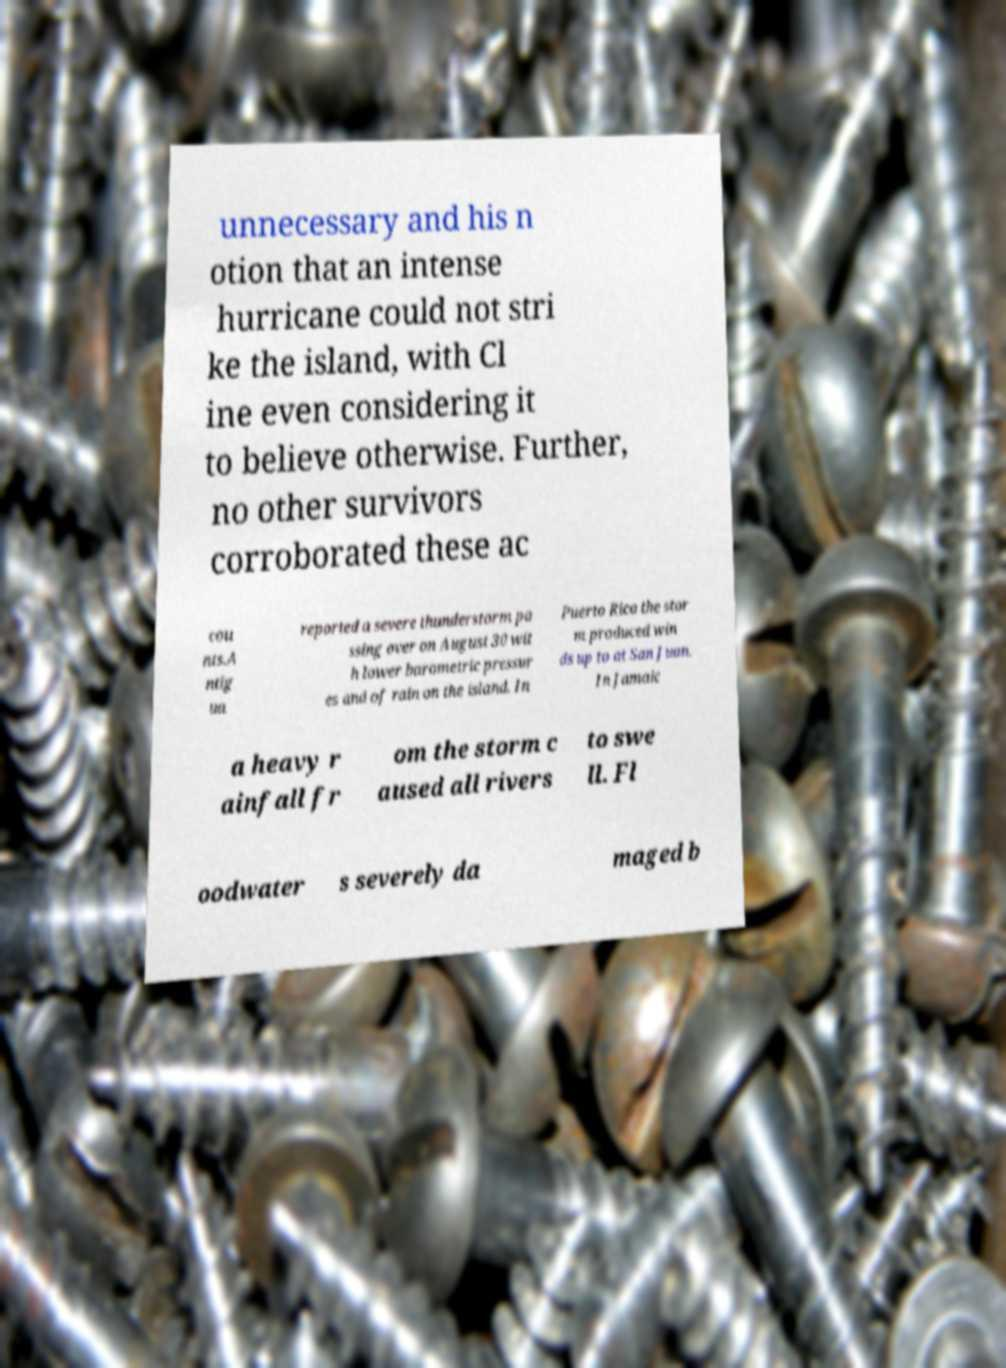Can you read and provide the text displayed in the image?This photo seems to have some interesting text. Can you extract and type it out for me? unnecessary and his n otion that an intense hurricane could not stri ke the island, with Cl ine even considering it to believe otherwise. Further, no other survivors corroborated these ac cou nts.A ntig ua reported a severe thunderstorm pa ssing over on August 30 wit h lower barometric pressur es and of rain on the island. In Puerto Rico the stor m produced win ds up to at San Juan. In Jamaic a heavy r ainfall fr om the storm c aused all rivers to swe ll. Fl oodwater s severely da maged b 